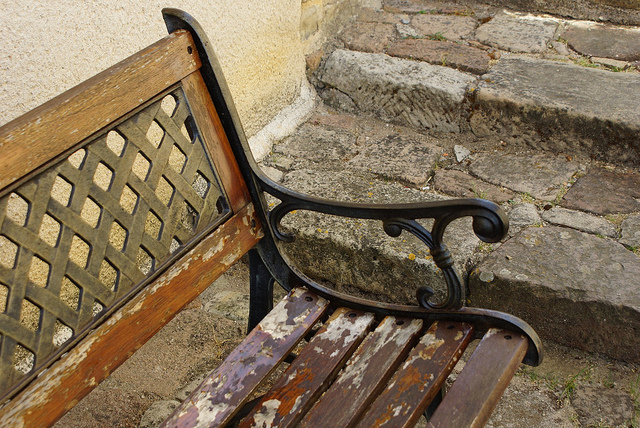Besides wood, what is the bench made of? The bench incorporates metal elements, particularly in the armrests and support structure, providing a sturdy and decorative contrast to the wooden slats. 